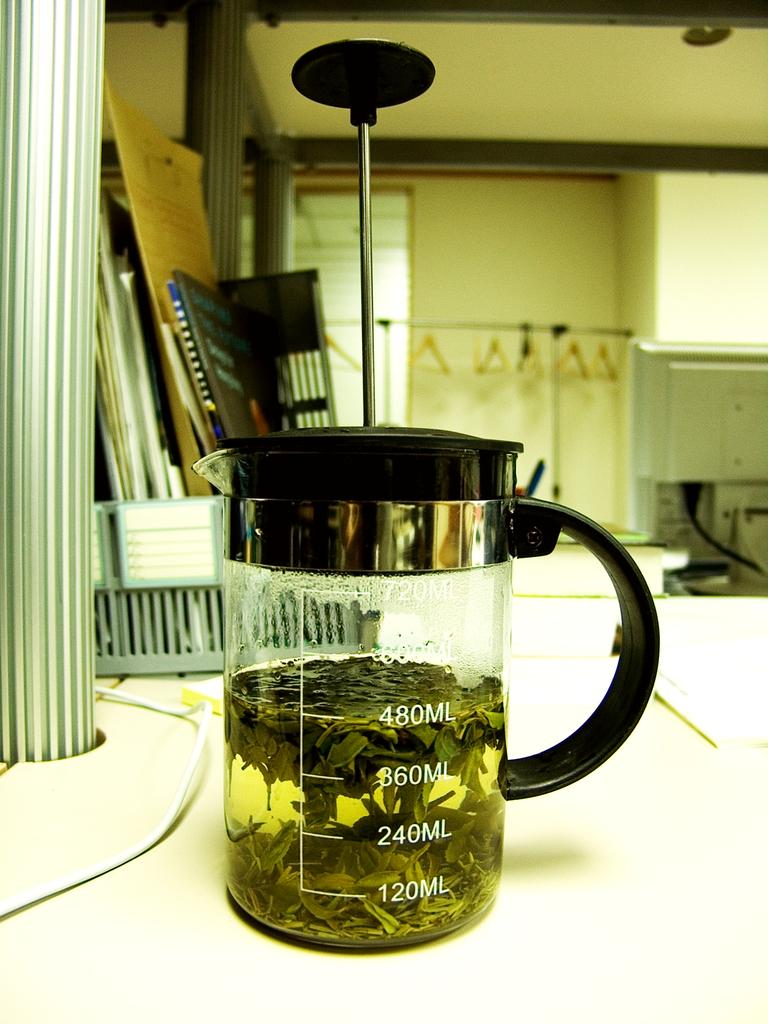<image>
Summarize the visual content of the image. The jar can hold a maximum of 720 milliliters of fluid 